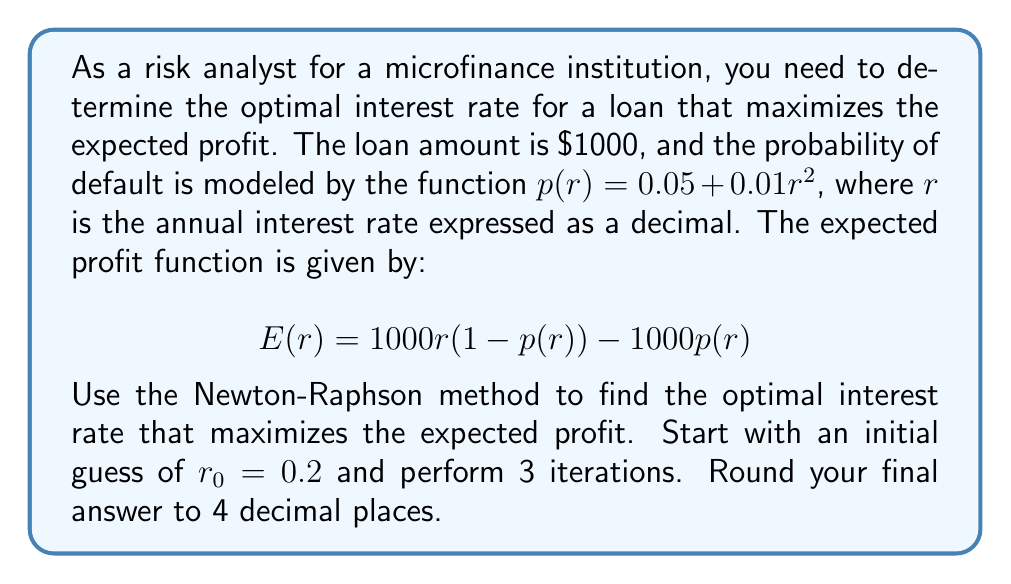Teach me how to tackle this problem. To find the optimal interest rate using the Newton-Raphson method, we need to follow these steps:

1) First, we need to find the derivative of the expected profit function $E(r)$:

   $E(r) = 1000r(1-p(r)) - 1000p(r)$
   $E(r) = 1000r(1-(0.05 + 0.01r^2)) - 1000(0.05 + 0.01r^2)$
   $E(r) = 1000r(0.95 - 0.01r^2) - 50 - 10r^2$
   $E(r) = 950r - 10r^3 - 50 - 10r^2$

   $E'(r) = 950 - 30r^2 - 20r$

2) The Newton-Raphson formula is:

   $r_{n+1} = r_n - \frac{E'(r_n)}{E''(r_n)}$

   Where $E''(r) = -60r - 20$

3) Now, let's perform 3 iterations:

   Iteration 1:
   $r_1 = 0.2 - \frac{950 - 30(0.2)^2 - 20(0.2)}{-60(0.2) - 20}$
   $r_1 = 0.2 - \frac{950 - 1.2 - 4}{-12 - 20}$
   $r_1 = 0.2 - \frac{944.8}{-32} = 0.2 + 29.525 = 29.725$

   Iteration 2:
   $r_2 = 29.725 - \frac{950 - 30(29.725)^2 - 20(29.725)}{-60(29.725) - 20}$
   $r_2 = 29.725 - \frac{950 - 26505.1875 - 594.5}{-1783.5 - 20}$
   $r_2 = 29.725 - \frac{-26149.6875}{-1803.5} = 29.725 - 14.4993 = 15.2257$

   Iteration 3:
   $r_3 = 15.2257 - \frac{950 - 30(15.2257)^2 - 20(15.2257)}{-60(15.2257) - 20}$
   $r_3 = 15.2257 - \frac{950 - 6961.5225 - 304.514}{-913.542 - 20}$
   $r_3 = 15.2257 - \frac{-6316.0365}{-933.542} = 15.2257 - 6.7657 = 8.4600$

4) Rounding to 4 decimal places, we get 8.4600.
Answer: 8.4600 